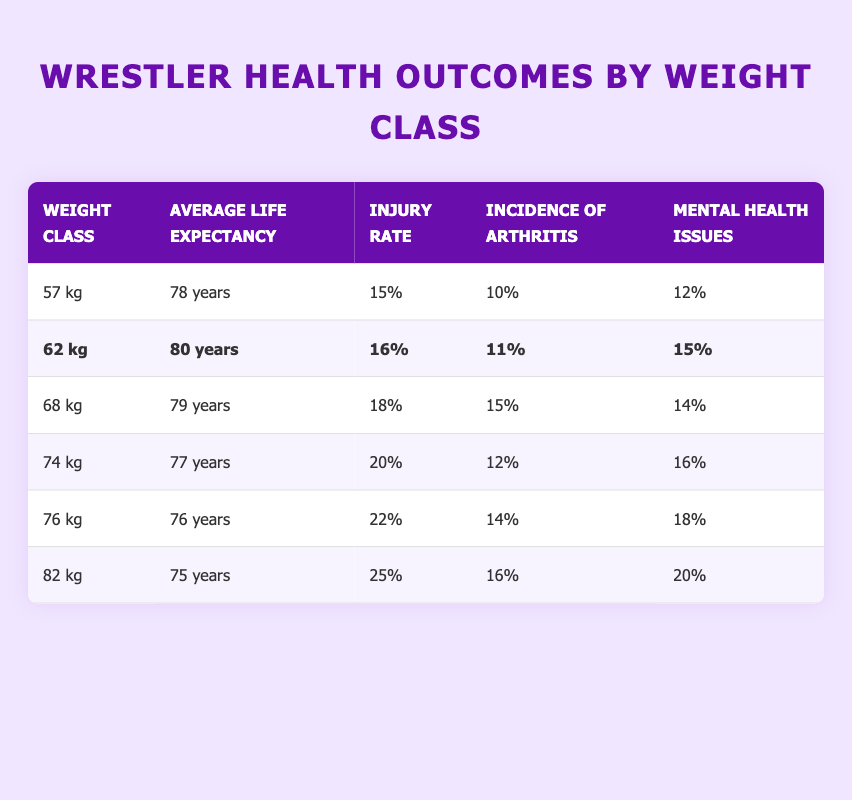What is the average life expectancy for the 62 kg weight class? The average life expectancy for the 62 kg weight class is directly given in the table, which states it is 80 years.
Answer: 80 years Which weight class has the highest injury rate? Reviewing the injury rates from all weight classes in the table, the highest injury rate is for the 82 kg class at 25%.
Answer: 82 kg What is the difference in average life expectancy between the 57 kg and 74 kg weight classes? The average life expectancy for the 57 kg class is 78 years, and for the 74 kg class, it is 77 years. The difference is calculated as 78 - 77 = 1 year.
Answer: 1 year Is the incidence of arthritis higher in the 76 kg weight class compared to the 62 kg class? The table shows the incidence of arthritis for the 76 kg class is 14%, whereas for the 62 kg class, it is 11%. Since 14% is greater than 11%, the statement is true.
Answer: Yes What is the average life expectancy across all weight classes listed in the table? To calculate the average life expectancy, we sum the life expectancy values (78 + 80 + 79 + 77 + 76 + 75) = 465 years and divide by the number of weight classes (6). So, 465 / 6 = 77.5 years.
Answer: 77.5 years Are mental health issues more prevalent in the 68 kg class compared to the 74 kg class? The table states that 14% of wrestlers in the 68 kg class have mental health issues and 16% in the 74 kg class. Since 16% is greater than 14%, the statement is false.
Answer: No What is the average incidence of arthritis for classes heavier than 62 kg? The weight classes heavier than 62 kg are 68 kg, 74 kg, 76 kg, and 82 kg. Their arthritis incidences are 15%, 12%, 14%, and 16% respectively. We sum these values (15 + 12 + 14 + 16 = 57) and divide by 4 to get the average: 57 / 4 = 14.25%.
Answer: 14.25% Which weight class has the highest average life expectancy and what is it? By reviewing the average life expectancy values in the table, the highest is 80 years for the 62 kg weight class.
Answer: 62 kg, 80 years What percentage of wrestlers in the 76 kg class have mental health issues? The table directly states that the percentage of mental health issues for the 76 kg class is 18%.
Answer: 18% 